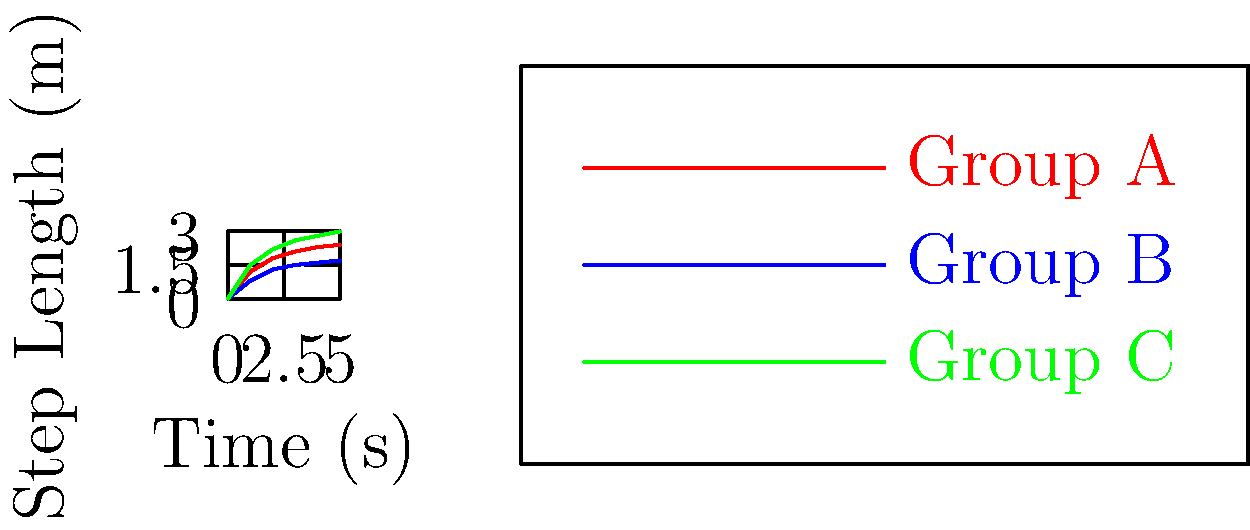In a comparative study of gait patterns among individuals in various social roles, three distinct groups were identified: Group A (middle managers), Group B (factory workers), and Group C (executives). Based on the graph showing step length over time, which group demonstrates the most significant increase in step length, and what might this suggest about their social role and status within the organization? To answer this question, we need to analyze the graph and consider the social implications of gait patterns:

1. Examine the graph:
   - Group A (red line): Shows a moderate increase in step length over time.
   - Group B (blue line): Displays the least increase in step length.
   - Group C (green line): Exhibits the steepest and most significant increase in step length.

2. Compare the slopes:
   - Group C has the steepest slope, indicating the most rapid increase in step length.
   - Group A has a moderate slope.
   - Group B has the gentlest slope.

3. Interpret the data:
   - Larger step lengths and faster increases often correlate with confidence, authority, and higher social status.
   - Group C (executives) shows the most significant increase, suggesting they may have the highest social status and confidence.
   - Group B (factory workers) shows the least increase, potentially indicating a more constrained or routine movement pattern.

4. Consider social implications:
   - Executives (Group C) may have more freedom of movement, less time constraints, and higher confidence in their workplace.
   - Middle managers (Group A) show a moderate pattern, possibly reflecting their intermediate status.
   - Factory workers (Group B) may have more restricted movement due to their work environment or time pressures.

5. Conclusion:
   Group C (executives) demonstrates the most significant increase in step length, suggesting a higher social status, more confidence, and potentially more power within the organization.
Answer: Group C (executives), indicating higher social status and confidence. 